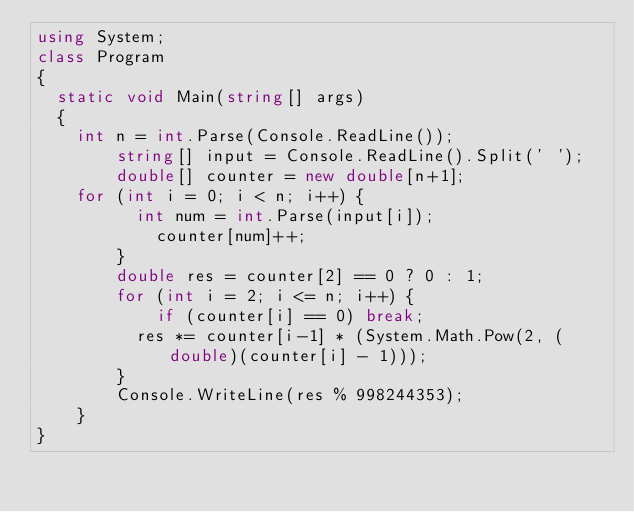Convert code to text. <code><loc_0><loc_0><loc_500><loc_500><_C#_>using System;
class Program
{
	static void Main(string[] args)
	{
		int n = int.Parse(Console.ReadLine());
      	string[] input = Console.ReadLine().Split(' ');
      	double[] counter = new double[n+1];
		for (int i = 0; i < n; i++) {
        	int num = int.Parse(input[i]);
          	counter[num]++;
        }
      	double res = counter[2] == 0 ? 0 : 1;
      	for (int i = 2; i <= n; i++) {
          	if (counter[i] == 0) break;
        	res *= counter[i-1] * (System.Math.Pow(2, (double)(counter[i] - 1)));
        }
      	Console.WriteLine(res % 998244353); 	
    }
}</code> 